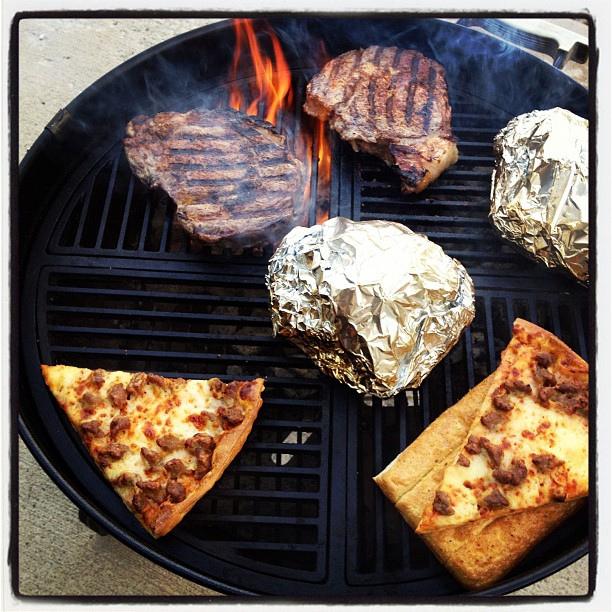Is there meat in the picture?
Keep it brief. Yes. Is this a pizza oven?
Keep it brief. No. What is in the middle?
Quick response, please. Foil wrapped food. 